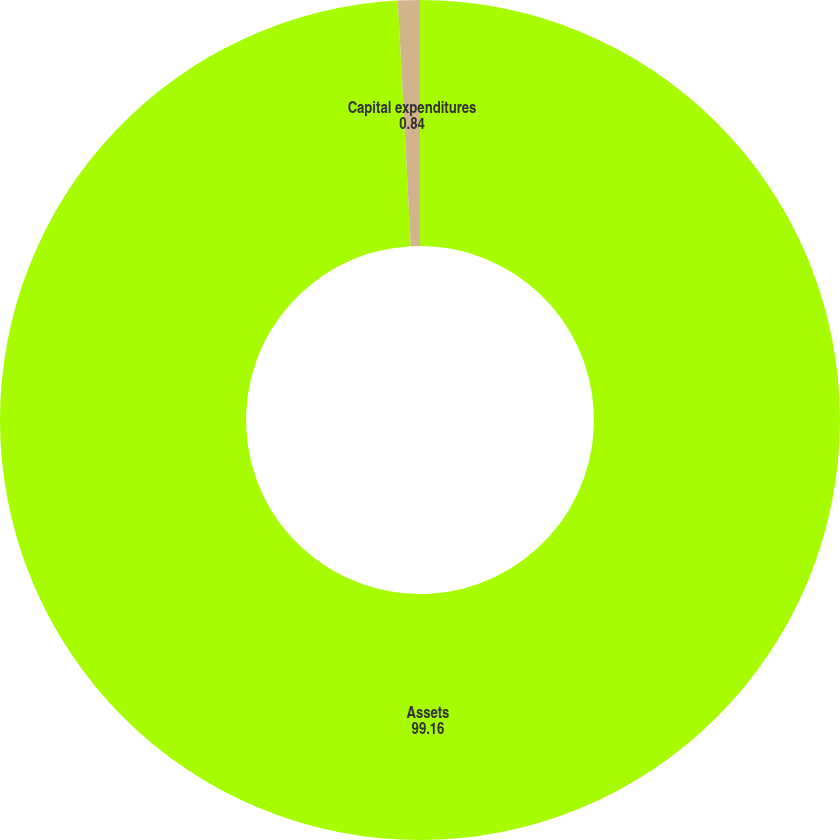Convert chart to OTSL. <chart><loc_0><loc_0><loc_500><loc_500><pie_chart><fcel>Assets<fcel>Capital expenditures<nl><fcel>99.16%<fcel>0.84%<nl></chart> 